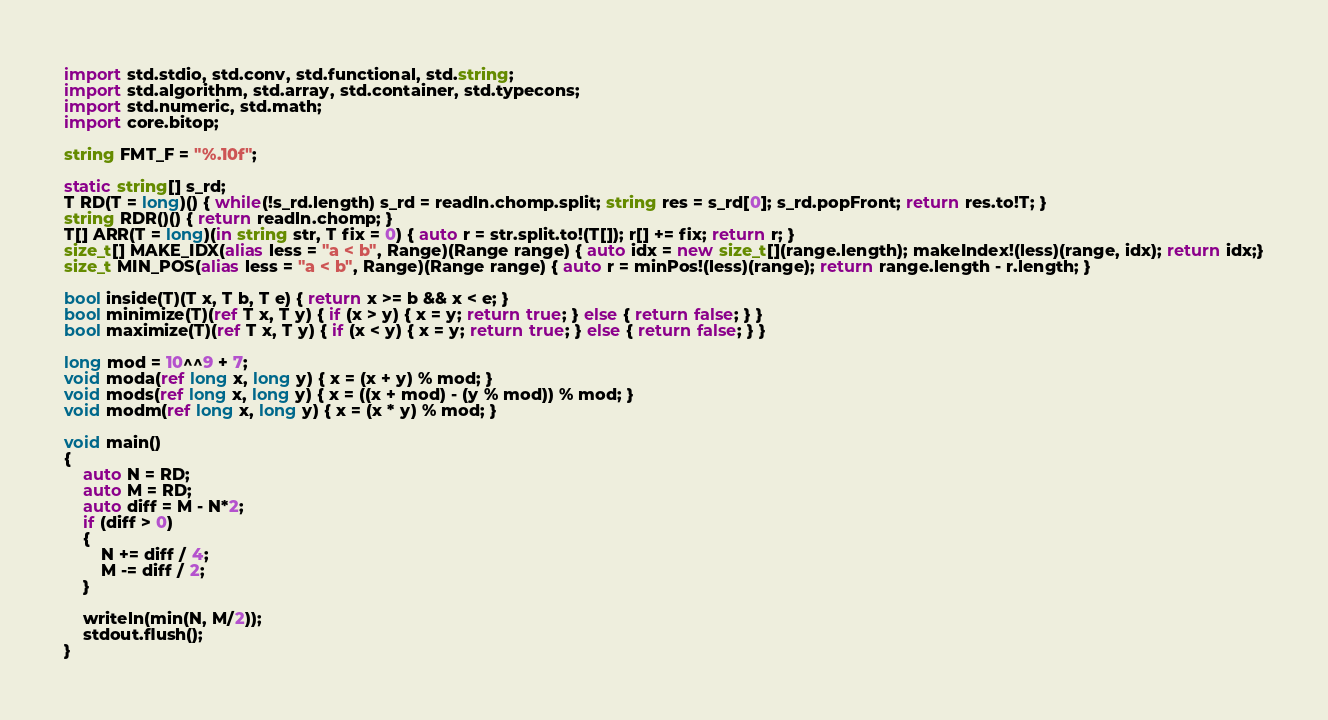<code> <loc_0><loc_0><loc_500><loc_500><_D_>import std.stdio, std.conv, std.functional, std.string;
import std.algorithm, std.array, std.container, std.typecons;
import std.numeric, std.math;
import core.bitop;

string FMT_F = "%.10f";

static string[] s_rd;
T RD(T = long)() { while(!s_rd.length) s_rd = readln.chomp.split; string res = s_rd[0]; s_rd.popFront; return res.to!T; }
string RDR()() { return readln.chomp; }
T[] ARR(T = long)(in string str, T fix = 0) { auto r = str.split.to!(T[]); r[] += fix; return r; }
size_t[] MAKE_IDX(alias less = "a < b", Range)(Range range) { auto idx = new size_t[](range.length); makeIndex!(less)(range, idx); return idx;}
size_t MIN_POS(alias less = "a < b", Range)(Range range) { auto r = minPos!(less)(range); return range.length - r.length; }

bool inside(T)(T x, T b, T e) { return x >= b && x < e; }
bool minimize(T)(ref T x, T y) { if (x > y) { x = y; return true; } else { return false; } }
bool maximize(T)(ref T x, T y) { if (x < y) { x = y; return true; } else { return false; } }

long mod = 10^^9 + 7;
void moda(ref long x, long y) { x = (x + y) % mod; }
void mods(ref long x, long y) { x = ((x + mod) - (y % mod)) % mod; }
void modm(ref long x, long y) { x = (x * y) % mod; }

void main()
{
	auto N = RD;
	auto M = RD;
	auto diff = M - N*2;
	if (diff > 0)
	{
		N += diff / 4;
		M -= diff / 2;
	}

	writeln(min(N, M/2));
	stdout.flush();
}</code> 